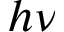<formula> <loc_0><loc_0><loc_500><loc_500>h \nu</formula> 